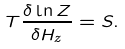Convert formula to latex. <formula><loc_0><loc_0><loc_500><loc_500>T \frac { \delta \ln Z } { \delta H _ { z } } = S .</formula> 